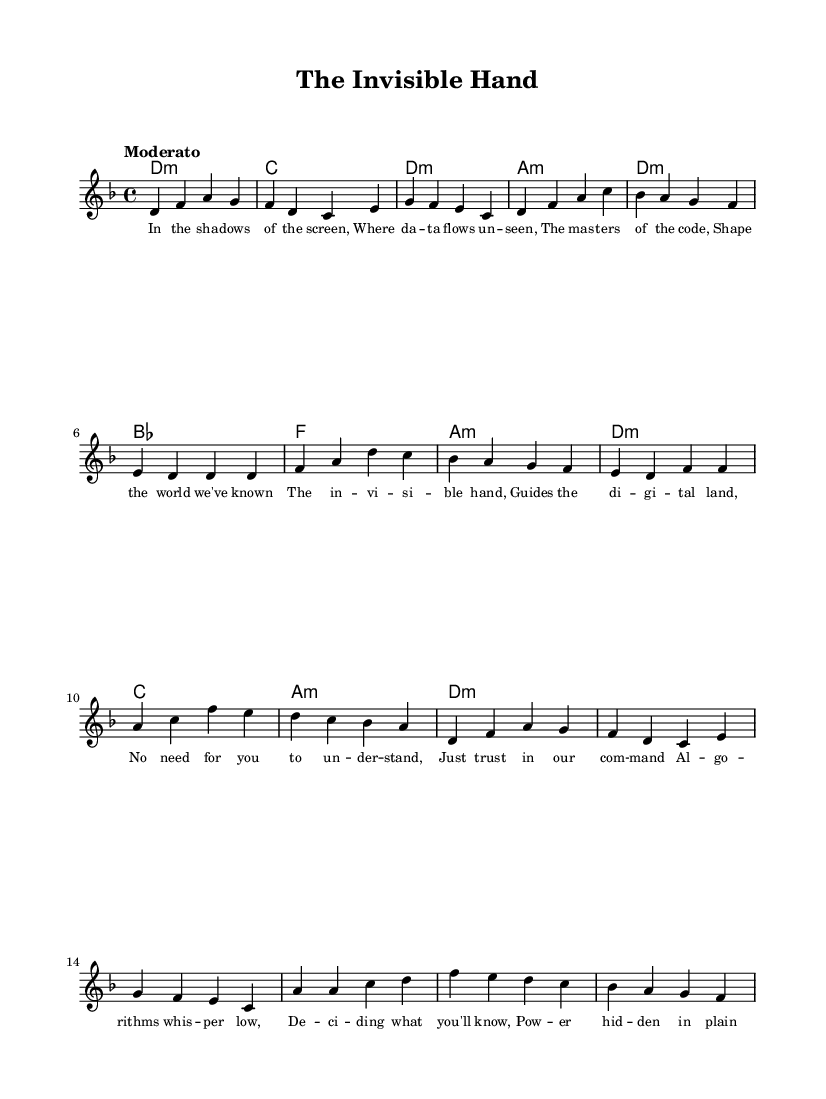What is the key signature of this music? The key signature is indicated in the score, and it shows two flats, which typically corresponds to the key of D minor.
Answer: D minor What is the time signature of this piece? The time signature is shown at the beginning of the score. It is written as a fraction, and here it indicates that there are four beats in each measure, which is represented by 4/4.
Answer: 4/4 What is the tempo marking for this piece? The tempo marking is provided in italics above the staff. It specifies "Moderato," indicating a moderate speed for the piece.
Answer: Moderato How many verses are present in the song? By examining the lyrics provided in the score, we can count the sections labeled as verses. There are two distinct verses indicated before the bridge.
Answer: Two What is the primary theme of the lyrics? The lyrics describe a metaphorical concept related to corporate influence and control in the digital world, highlighting unseen power dynamics.
Answer: Corporate power Which chord begins the chorus section? To determine this, we can look at the chord chart aligned with the lyrics. The first chord listed under the chorus lyrics is D minor.
Answer: D minor How is the bridge section structured musically compared to the verses? The bridge has a different melodic line and harmony from the verses. Its structure is shortened and distinct, as can be seen by examining the music notation and lyrics for contrast.
Answer: Shortened and distinct 